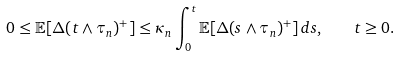Convert formula to latex. <formula><loc_0><loc_0><loc_500><loc_500>0 \leq \mathbb { E } [ \Delta ( t \wedge \tau _ { n } ) ^ { + } ] \leq \kappa _ { n } \int _ { 0 } ^ { t } \mathbb { E } [ \Delta ( s \wedge \tau _ { n } ) ^ { + } ] \, d s , \quad t \geq 0 .</formula> 